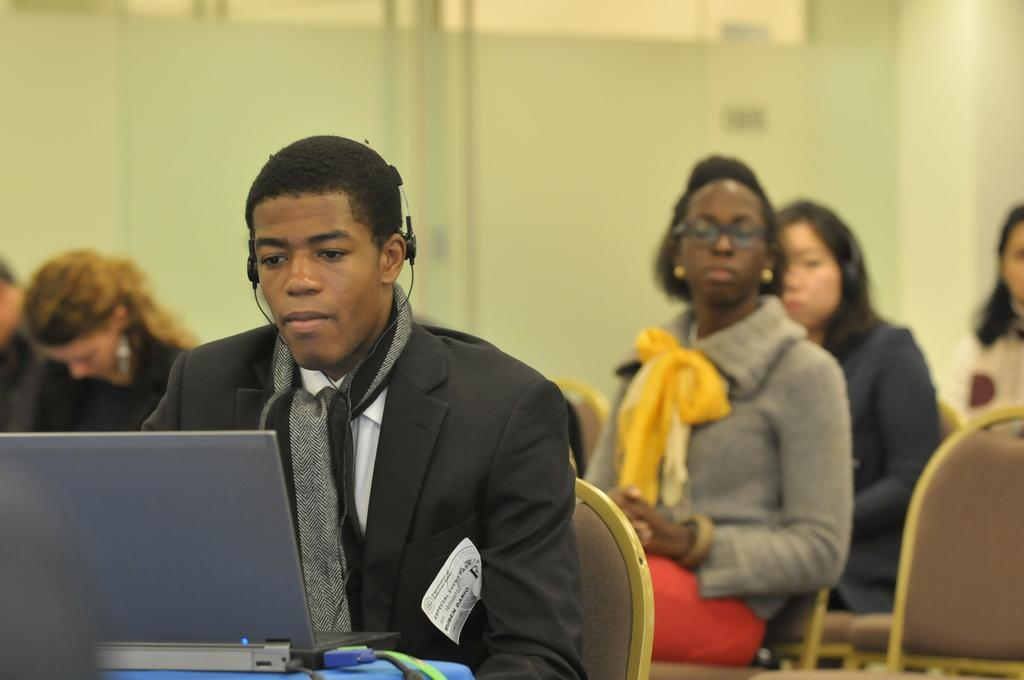What color is the wall in the image? There is a yellow color wall in the image. What are the people in the image doing? The people in the image are sitting on chairs. What electronic device can be seen in the image? There is a laptop visible in the image. Can you tell me how deep the river is in the image? There is no river present in the image; it features a yellow color wall, people sitting on chairs, and a laptop. 